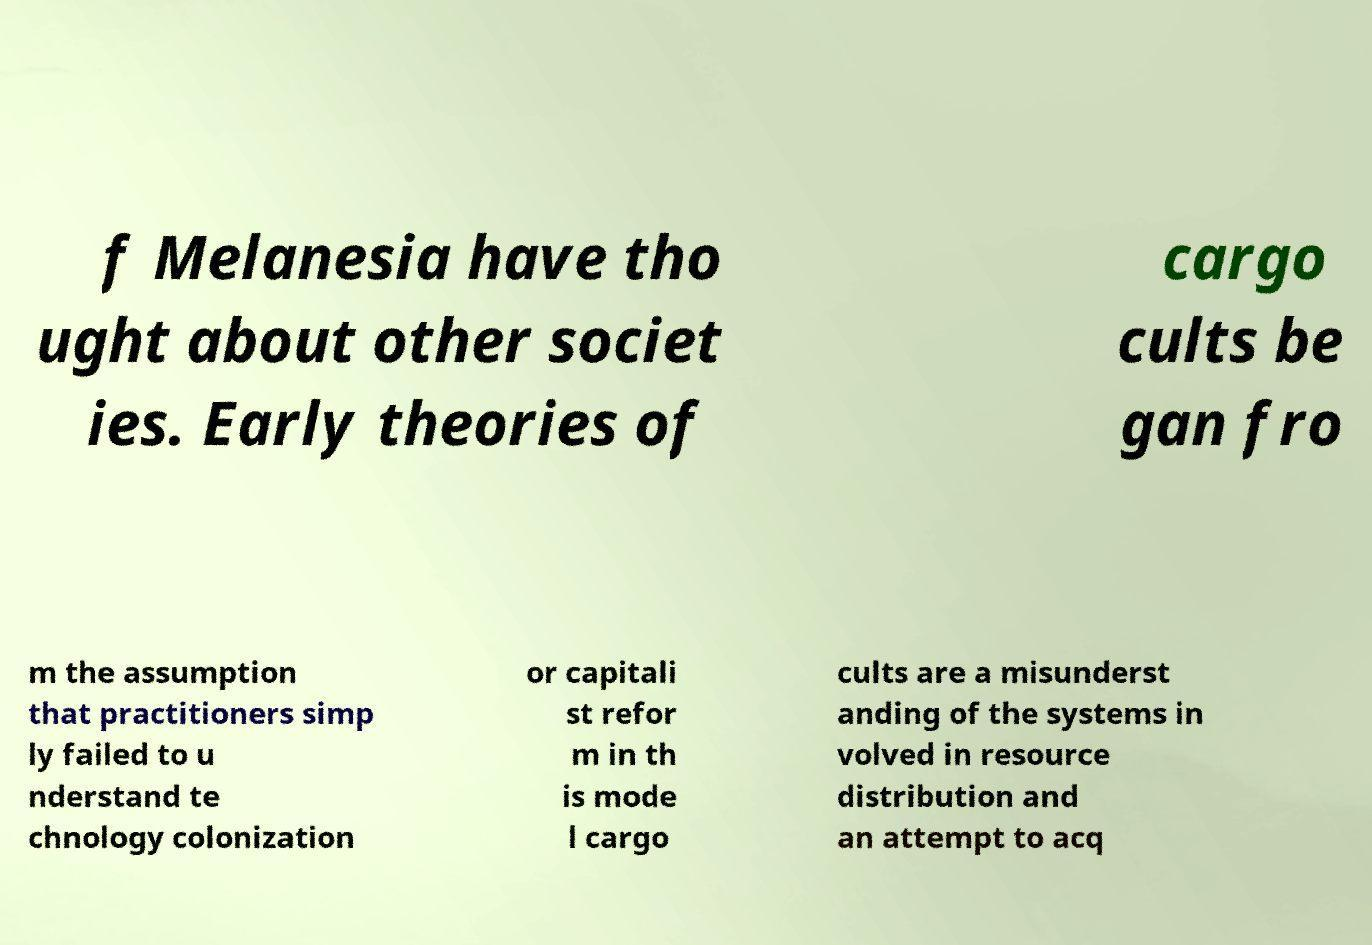Please identify and transcribe the text found in this image. f Melanesia have tho ught about other societ ies. Early theories of cargo cults be gan fro m the assumption that practitioners simp ly failed to u nderstand te chnology colonization or capitali st refor m in th is mode l cargo cults are a misunderst anding of the systems in volved in resource distribution and an attempt to acq 